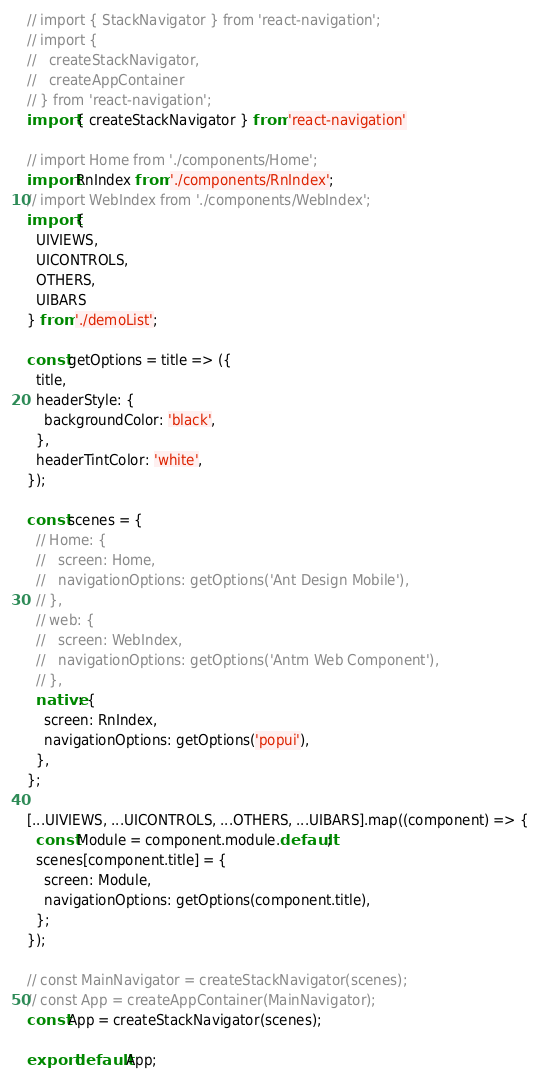Convert code to text. <code><loc_0><loc_0><loc_500><loc_500><_JavaScript_>// import { StackNavigator } from 'react-navigation';
// import {
//   createStackNavigator,
//   createAppContainer
// } from 'react-navigation';
import { createStackNavigator } from 'react-navigation'

// import Home from './components/Home';
import RnIndex from './components/RnIndex';
// import WebIndex from './components/WebIndex';
import {
  UIVIEWS,
  UICONTROLS,
  OTHERS,
  UIBARS
} from './demoList';

const getOptions = title => ({
  title,
  headerStyle: {
    backgroundColor: 'black',
  },
  headerTintColor: 'white',
});

const scenes = {
  // Home: {
  //   screen: Home,
  //   navigationOptions: getOptions('Ant Design Mobile'),
  // },
  // web: {
  //   screen: WebIndex,
  //   navigationOptions: getOptions('Antm Web Component'),
  // },
  native: {
    screen: RnIndex,
    navigationOptions: getOptions('popui'),
  },
};

[...UIVIEWS, ...UICONTROLS, ...OTHERS, ...UIBARS].map((component) => {
  const Module = component.module.default;
  scenes[component.title] = {
    screen: Module,
    navigationOptions: getOptions(component.title),
  };
});

// const MainNavigator = createStackNavigator(scenes);
// const App = createAppContainer(MainNavigator);
const App = createStackNavigator(scenes);

export default App;
</code> 